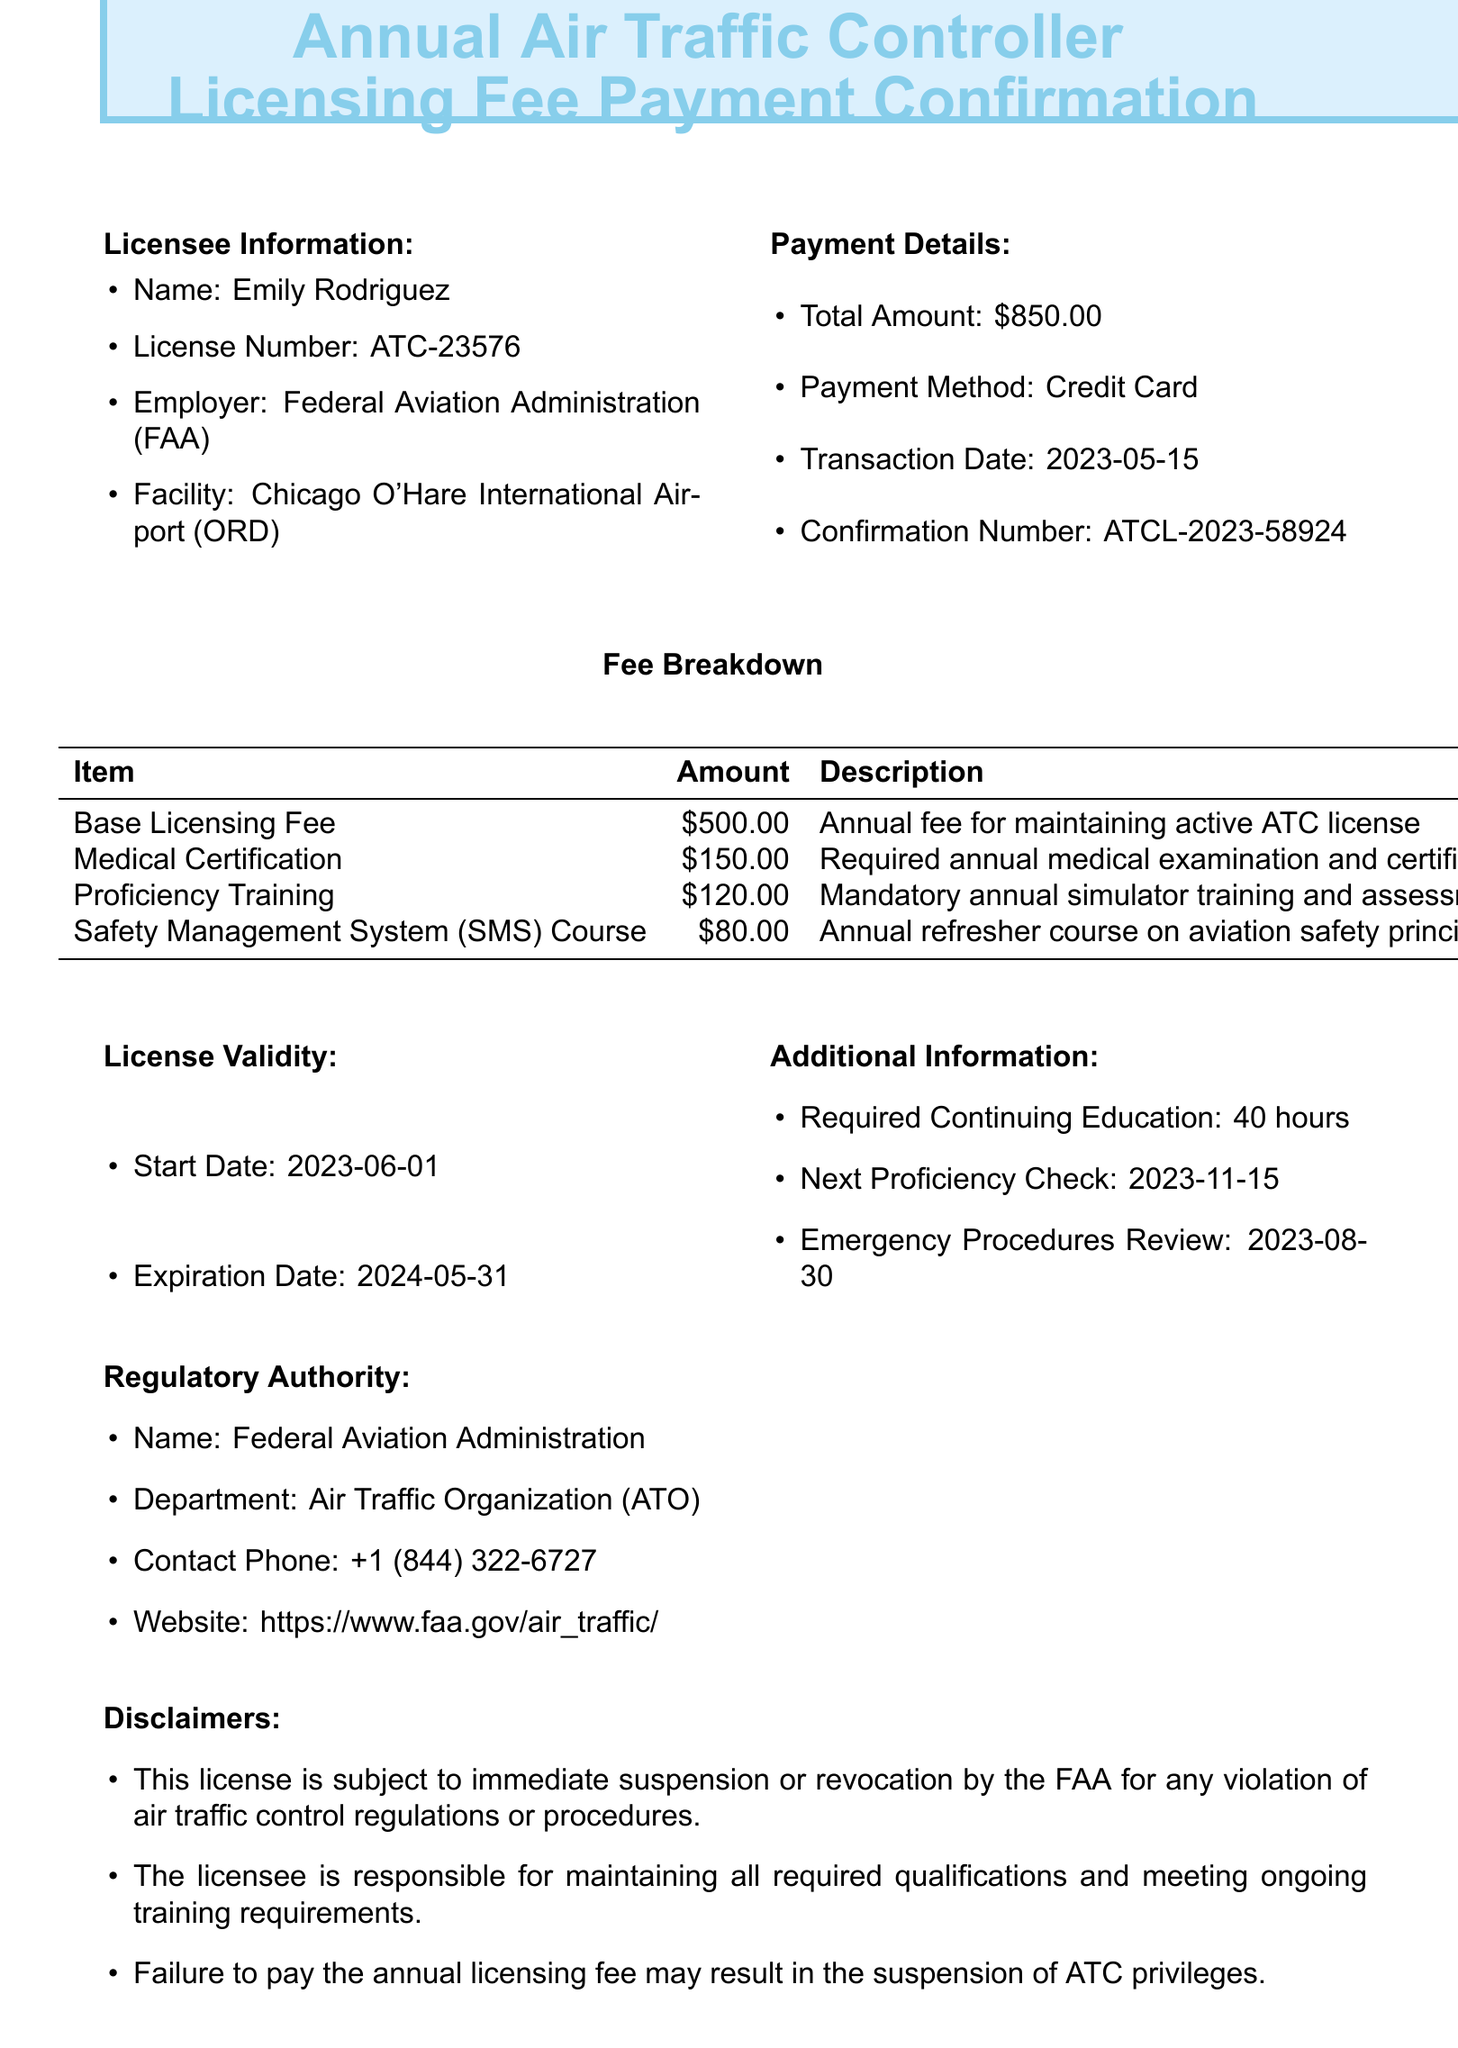What is the name of the licensee? The document states that the licensee's name is Emily Rodriguez.
Answer: Emily Rodriguez What is the total amount paid? The total payment amount mentioned in the document is $850.00.
Answer: $850.00 What is the license number? The license number provided in the document is ATC-23576.
Answer: ATC-23576 When is the next proficiency check? The document indicates that the next proficiency check is scheduled for 2023-11-15.
Answer: 2023-11-15 What is the base licensing fee? According to the fee breakdown, the base licensing fee is $500.00.
Answer: $500.00 How many hours of continuing education are required? The required continuing education hours stated in the document is 40 hours.
Answer: 40 hours What payment method was used? The document specifies that the payment method was a credit card.
Answer: Credit Card When does the license expire? The document shows that the expiration date of the license is 2024-05-31.
Answer: 2024-05-31 What is the contact phone number for the regulatory authority? The document provides the contact phone number for the FAA as +1 (844) 322-6727.
Answer: +1 (844) 322-6727 